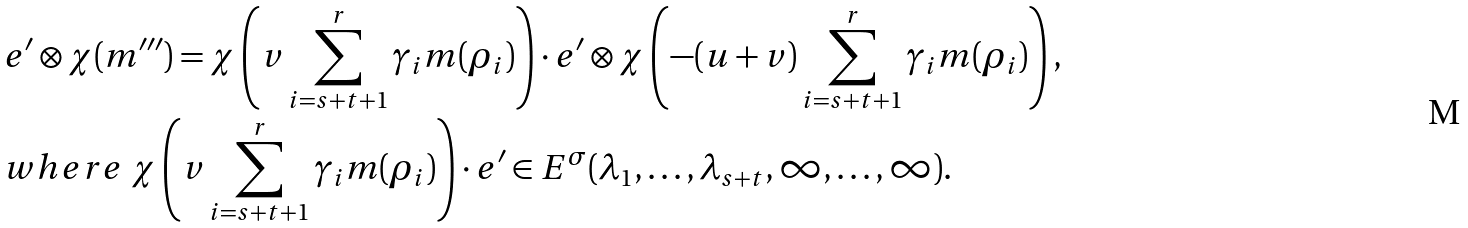Convert formula to latex. <formula><loc_0><loc_0><loc_500><loc_500>& e ^ { \prime } \otimes \chi ( m ^ { \prime \prime \prime } ) = \chi \left ( v \sum _ { i = s + t + 1 } ^ { r } \gamma _ { i } m ( \rho _ { i } ) \right ) \cdot e ^ { \prime } \otimes \chi \left ( - ( u + v ) \sum _ { i = s + t + 1 } ^ { r } \gamma _ { i } m ( \rho _ { i } ) \right ) , \\ & w h e r e \ \chi \left ( v \sum _ { i = s + t + 1 } ^ { r } \gamma _ { i } m ( \rho _ { i } ) \right ) \cdot e ^ { \prime } \in E ^ { \sigma } ( \lambda _ { 1 } , \dots , \lambda _ { s + t } , \infty , \dots , \infty ) .</formula> 